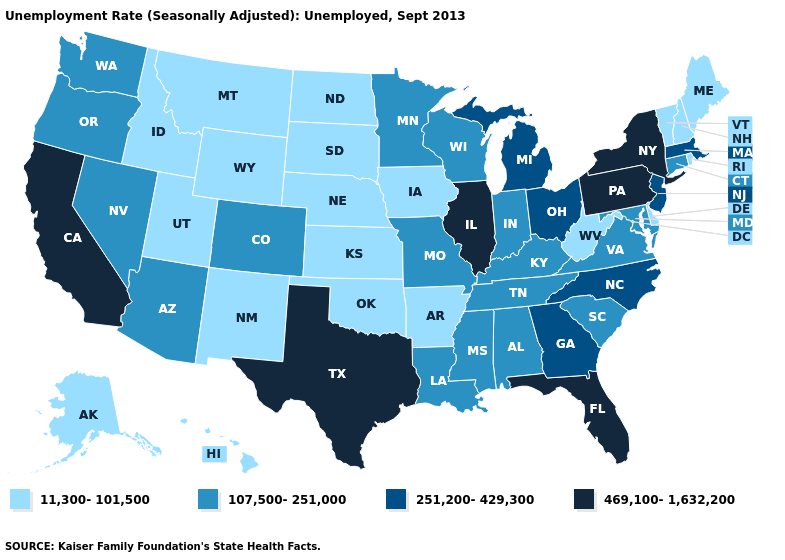What is the value of Tennessee?
Keep it brief. 107,500-251,000. Does the first symbol in the legend represent the smallest category?
Answer briefly. Yes. Name the states that have a value in the range 469,100-1,632,200?
Keep it brief. California, Florida, Illinois, New York, Pennsylvania, Texas. What is the value of Iowa?
Write a very short answer. 11,300-101,500. Among the states that border Indiana , which have the highest value?
Concise answer only. Illinois. Name the states that have a value in the range 251,200-429,300?
Write a very short answer. Georgia, Massachusetts, Michigan, New Jersey, North Carolina, Ohio. Is the legend a continuous bar?
Concise answer only. No. What is the lowest value in the Northeast?
Be succinct. 11,300-101,500. Does Illinois have the highest value in the MidWest?
Keep it brief. Yes. Which states hav the highest value in the MidWest?
Keep it brief. Illinois. Does the first symbol in the legend represent the smallest category?
Concise answer only. Yes. Among the states that border Illinois , does Kentucky have the highest value?
Keep it brief. Yes. Does Massachusetts have a higher value than California?
Write a very short answer. No. What is the highest value in states that border Nebraska?
Be succinct. 107,500-251,000. What is the lowest value in the USA?
Write a very short answer. 11,300-101,500. 